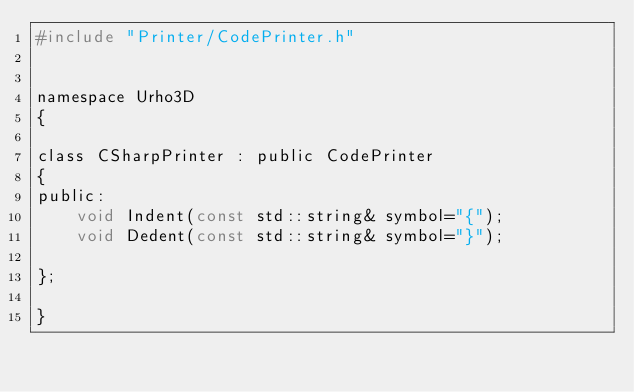Convert code to text. <code><loc_0><loc_0><loc_500><loc_500><_C_>#include "Printer/CodePrinter.h"


namespace Urho3D
{

class CSharpPrinter : public CodePrinter
{
public:
    void Indent(const std::string& symbol="{");
    void Dedent(const std::string& symbol="}");

};

}
</code> 